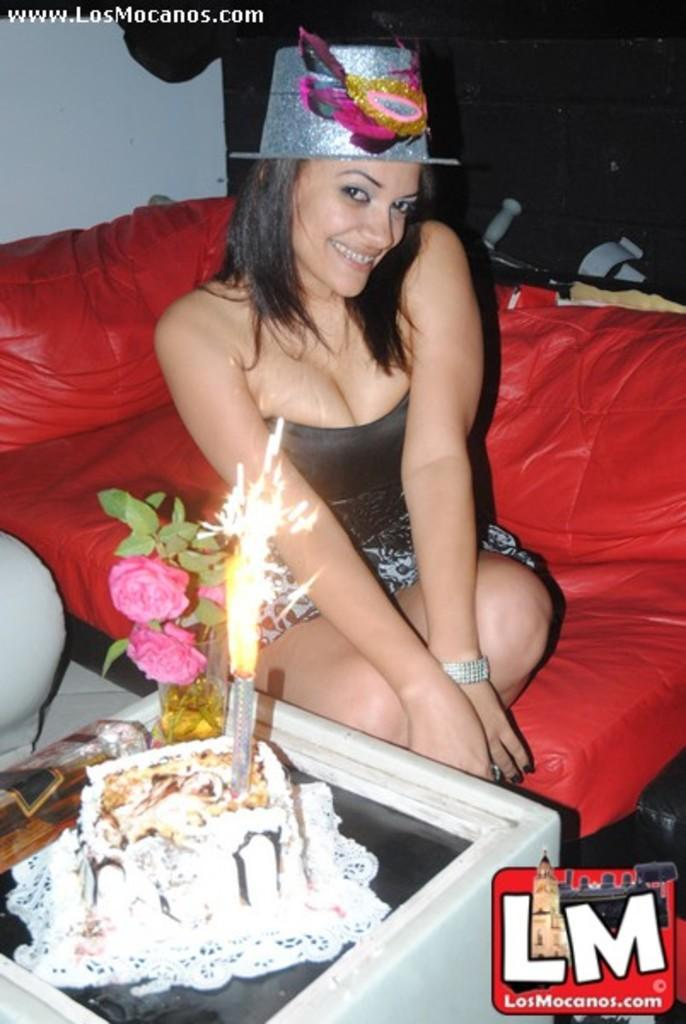Who is the main subject in the image? There is a girl in the center of the image. What is the girl doing in the image? The girl is sitting on a sofa. What is the girl wearing in the image? The girl is wearing a hat. What objects are in front of the girl? There is a cake and flowers in front of the girl. What type of coal is being used to fuel the fire in the image? There is no fire or coal present in the image; it features a girl sitting on a sofa with a cake and flowers in front of her. 